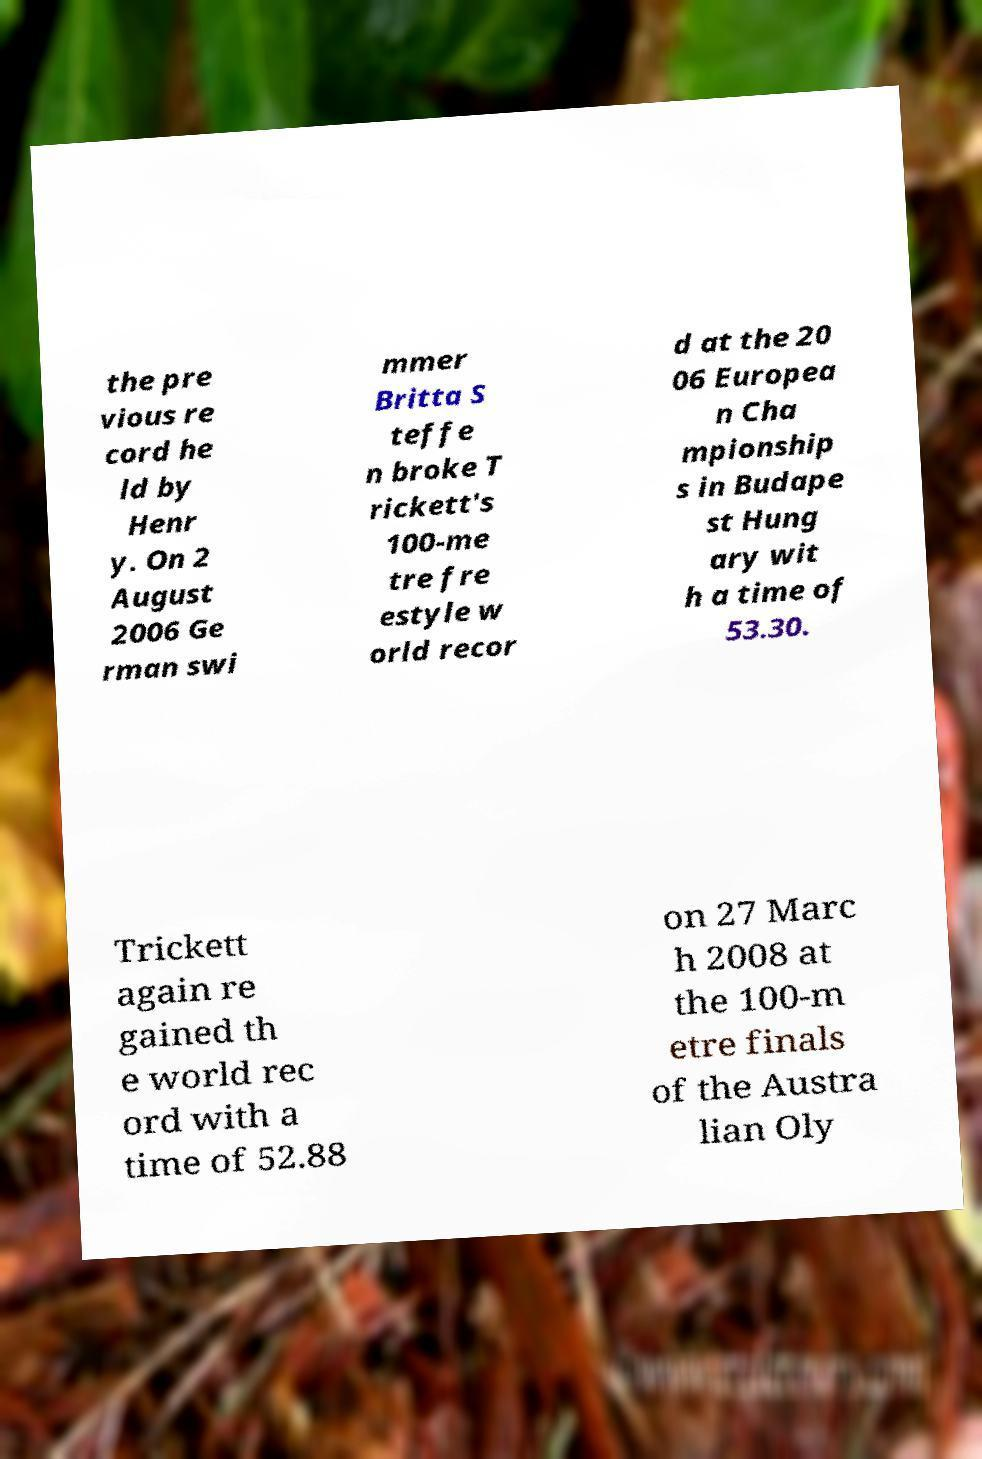Can you accurately transcribe the text from the provided image for me? the pre vious re cord he ld by Henr y. On 2 August 2006 Ge rman swi mmer Britta S teffe n broke T rickett's 100-me tre fre estyle w orld recor d at the 20 06 Europea n Cha mpionship s in Budape st Hung ary wit h a time of 53.30. Trickett again re gained th e world rec ord with a time of 52.88 on 27 Marc h 2008 at the 100-m etre finals of the Austra lian Oly 